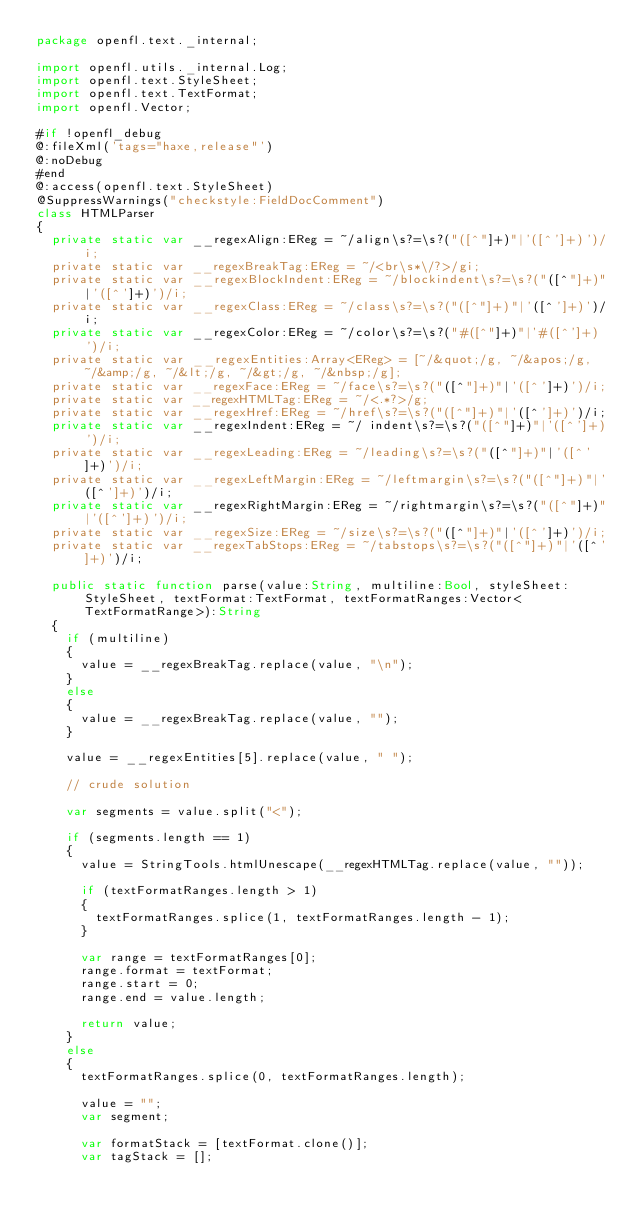Convert code to text. <code><loc_0><loc_0><loc_500><loc_500><_Haxe_>package openfl.text._internal;

import openfl.utils._internal.Log;
import openfl.text.StyleSheet;
import openfl.text.TextFormat;
import openfl.Vector;

#if !openfl_debug
@:fileXml('tags="haxe,release"')
@:noDebug
#end
@:access(openfl.text.StyleSheet)
@SuppressWarnings("checkstyle:FieldDocComment")
class HTMLParser
{
	private static var __regexAlign:EReg = ~/align\s?=\s?("([^"]+)"|'([^']+)')/i;
	private static var __regexBreakTag:EReg = ~/<br\s*\/?>/gi;
	private static var __regexBlockIndent:EReg = ~/blockindent\s?=\s?("([^"]+)"|'([^']+)')/i;
	private static var __regexClass:EReg = ~/class\s?=\s?("([^"]+)"|'([^']+)')/i;
	private static var __regexColor:EReg = ~/color\s?=\s?("#([^"]+)"|'#([^']+)')/i;
	private static var __regexEntities:Array<EReg> = [~/&quot;/g, ~/&apos;/g, ~/&amp;/g, ~/&lt;/g, ~/&gt;/g, ~/&nbsp;/g];
	private static var __regexFace:EReg = ~/face\s?=\s?("([^"]+)"|'([^']+)')/i;
	private static var __regexHTMLTag:EReg = ~/<.*?>/g;
	private static var __regexHref:EReg = ~/href\s?=\s?("([^"]+)"|'([^']+)')/i;
	private static var __regexIndent:EReg = ~/ indent\s?=\s?("([^"]+)"|'([^']+)')/i;
	private static var __regexLeading:EReg = ~/leading\s?=\s?("([^"]+)"|'([^']+)')/i;
	private static var __regexLeftMargin:EReg = ~/leftmargin\s?=\s?("([^"]+)"|'([^']+)')/i;
	private static var __regexRightMargin:EReg = ~/rightmargin\s?=\s?("([^"]+)"|'([^']+)')/i;
	private static var __regexSize:EReg = ~/size\s?=\s?("([^"]+)"|'([^']+)')/i;
	private static var __regexTabStops:EReg = ~/tabstops\s?=\s?("([^"]+)"|'([^']+)')/i;

	public static function parse(value:String, multiline:Bool, styleSheet:StyleSheet, textFormat:TextFormat, textFormatRanges:Vector<TextFormatRange>):String
	{
		if (multiline)
		{
			value = __regexBreakTag.replace(value, "\n");
		}
		else
		{
			value = __regexBreakTag.replace(value, "");
		}

		value = __regexEntities[5].replace(value, " ");

		// crude solution

		var segments = value.split("<");

		if (segments.length == 1)
		{
			value = StringTools.htmlUnescape(__regexHTMLTag.replace(value, ""));

			if (textFormatRanges.length > 1)
			{
				textFormatRanges.splice(1, textFormatRanges.length - 1);
			}

			var range = textFormatRanges[0];
			range.format = textFormat;
			range.start = 0;
			range.end = value.length;

			return value;
		}
		else
		{
			textFormatRanges.splice(0, textFormatRanges.length);

			value = "";
			var segment;

			var formatStack = [textFormat.clone()];
			var tagStack = [];</code> 